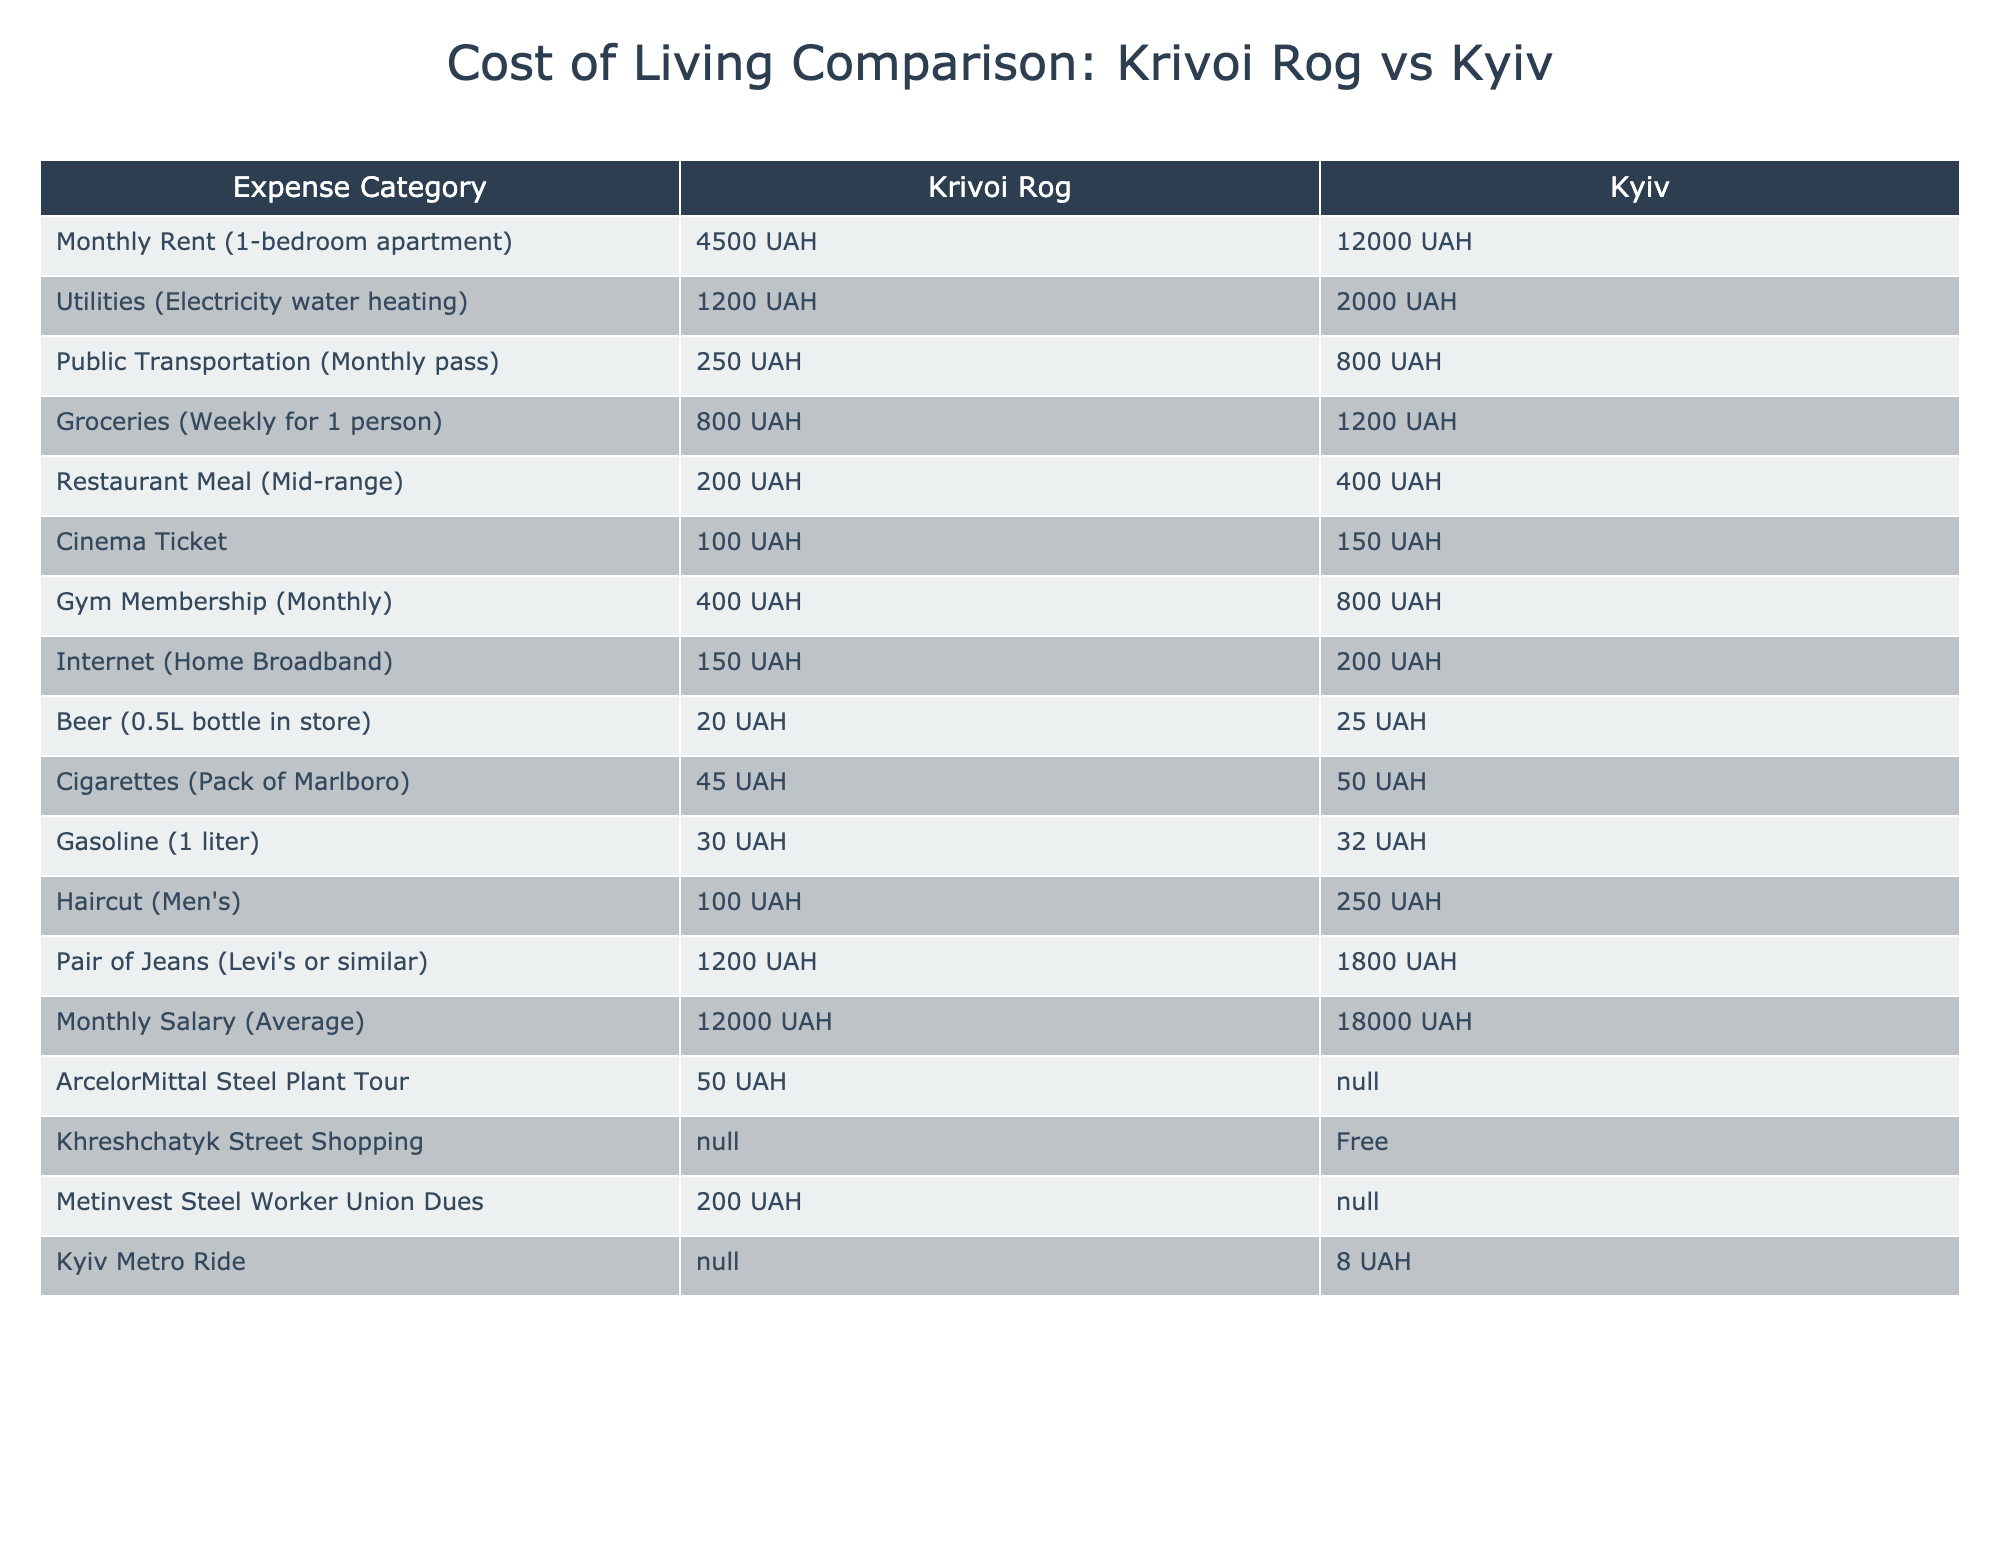What is the cost of a monthly rent for a one-bedroom apartment in Krivoi Rog? The table lists the cost of monthly rent for a one-bedroom apartment in Krivoi Rog as 4500 UAH.
Answer: 4500 UAH How much does a monthly transportation pass cost in Kyiv compared to Krivoi Rog? The table shows that a monthly transportation pass costs 800 UAH in Kyiv and 250 UAH in Krivoi Rog. Therefore, it is 550 UAH more expensive in Kyiv.
Answer: 550 UAH Is it cheaper to buy groceries weekly for one person in Krivoi Rog or Kyiv? The cost of weekly groceries for one person in Krivoi Rog is 800 UAH, while in Kyiv, it's 1200 UAH. Thus, it's cheaper in Krivoi Rog.
Answer: Yes, it's cheaper in Krivoi Rog What is the difference in cost for a meal at a mid-range restaurant between Krivoi Rog and Kyiv? The cost of a mid-range restaurant meal is 200 UAH in Krivoi Rog and 400 UAH in Kyiv. The difference is 400 UAH - 200 UAH = 200 UAH.
Answer: 200 UAH How much more expensive is the gym membership in Kyiv compared to Krivoi Rog? The monthly gym membership in Kyiv is 800 UAH, while in Krivoi Rog, it is 400 UAH. The cost difference is 800 UAH - 400 UAH = 400 UAH.
Answer: 400 UAH What percentage of the average monthly salary in Krivoi Rog is spent on utilities? The average monthly salary in Krivoi Rog is 12000 UAH. Monthly utilities cost is 1200 UAH. To find the percentage: (1200/12000) * 100 = 10%.
Answer: 10% What is the ratio of the cost for a cinema ticket between Krivoi Rog and Kyiv? In Krivoi Rog, a cinema ticket costs 100 UAH, while in Kyiv it costs 150 UAH. The ratio is 100:150, which can be simplified to 2:3.
Answer: 2:3 If a steel worker pays 200 UAH in union dues in Krivoi Rog, how much would he have left after paying for utilities? After paying for utility costs of 1200 UAH, the remaining amount would be 12000 UAH (salary) - 200 UAH (dues) - 1200 UAH (utilities) = 10600 UAH.
Answer: 10600 UAH Is the cost of a haircut in Krivoi Rog less than the cost in Kyiv? The cost of a haircut is 100 UAH in Krivoi Rog and 250 UAH in Kyiv. Therefore, it is less in Krivoi Rog.
Answer: Yes, it is less in Krivoi Rog What is the total cost of living (in UAH) per month when you sum rent, utilities, transportation, groceries, and a gym membership in Krivoi Rog? Summing up the relevant costs: 4500 UAH (rent) + 1200 UAH (utilities) + 250 UAH (transportation) + (800 UAH*4) (groceries for four weeks) + 400 UAH (gym) = 4500 + 1200 + 250 + 3200 + 400 = 9590 UAH.
Answer: 9590 UAH 